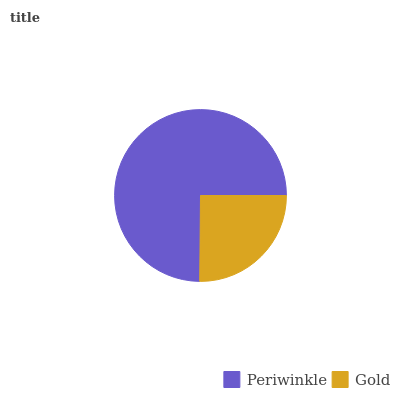Is Gold the minimum?
Answer yes or no. Yes. Is Periwinkle the maximum?
Answer yes or no. Yes. Is Gold the maximum?
Answer yes or no. No. Is Periwinkle greater than Gold?
Answer yes or no. Yes. Is Gold less than Periwinkle?
Answer yes or no. Yes. Is Gold greater than Periwinkle?
Answer yes or no. No. Is Periwinkle less than Gold?
Answer yes or no. No. Is Periwinkle the high median?
Answer yes or no. Yes. Is Gold the low median?
Answer yes or no. Yes. Is Gold the high median?
Answer yes or no. No. Is Periwinkle the low median?
Answer yes or no. No. 